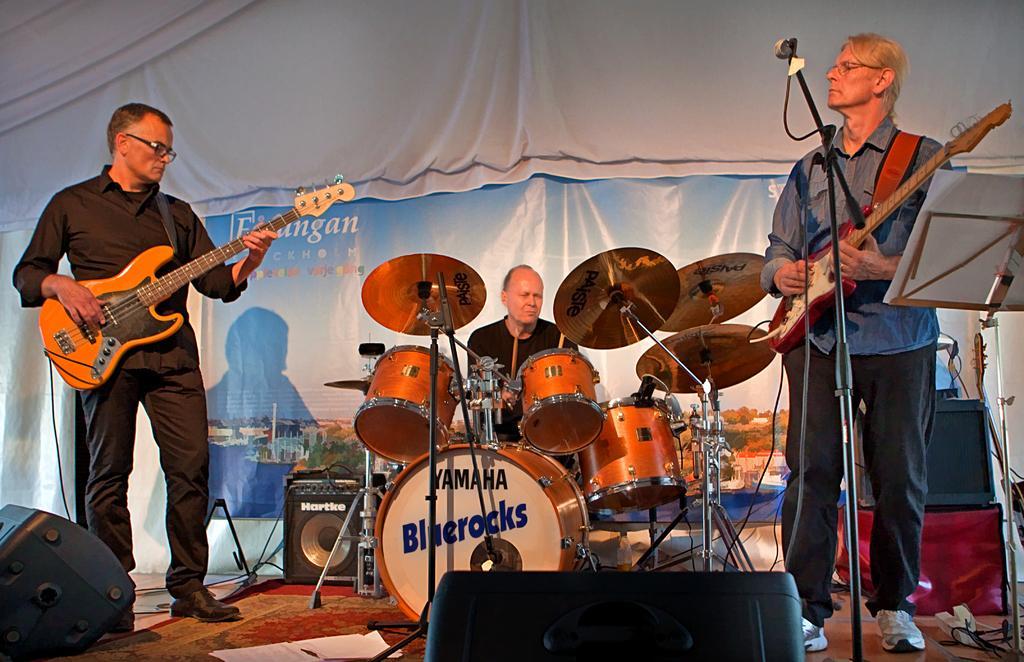Can you describe this image briefly? As we can see in the image there is a cloth, banner, three people over here and the man on the left and right side are holding guitars in their hands and the man is playing musical drums. 